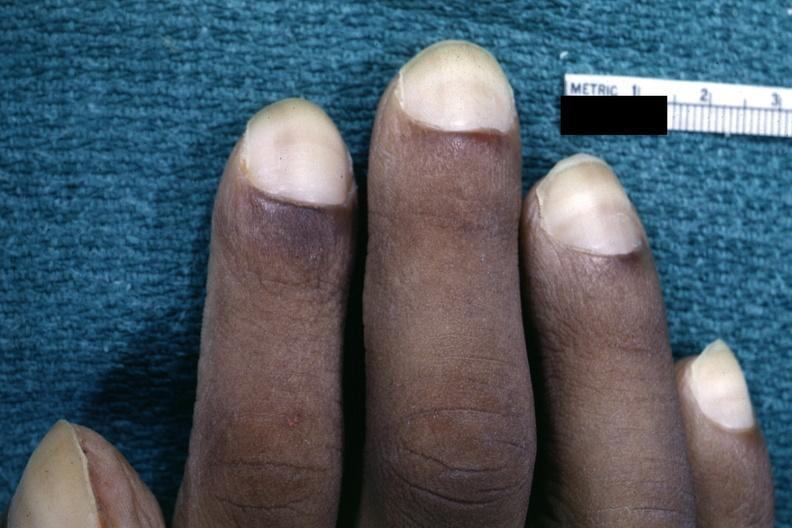re extremities present?
Answer the question using a single word or phrase. Yes 